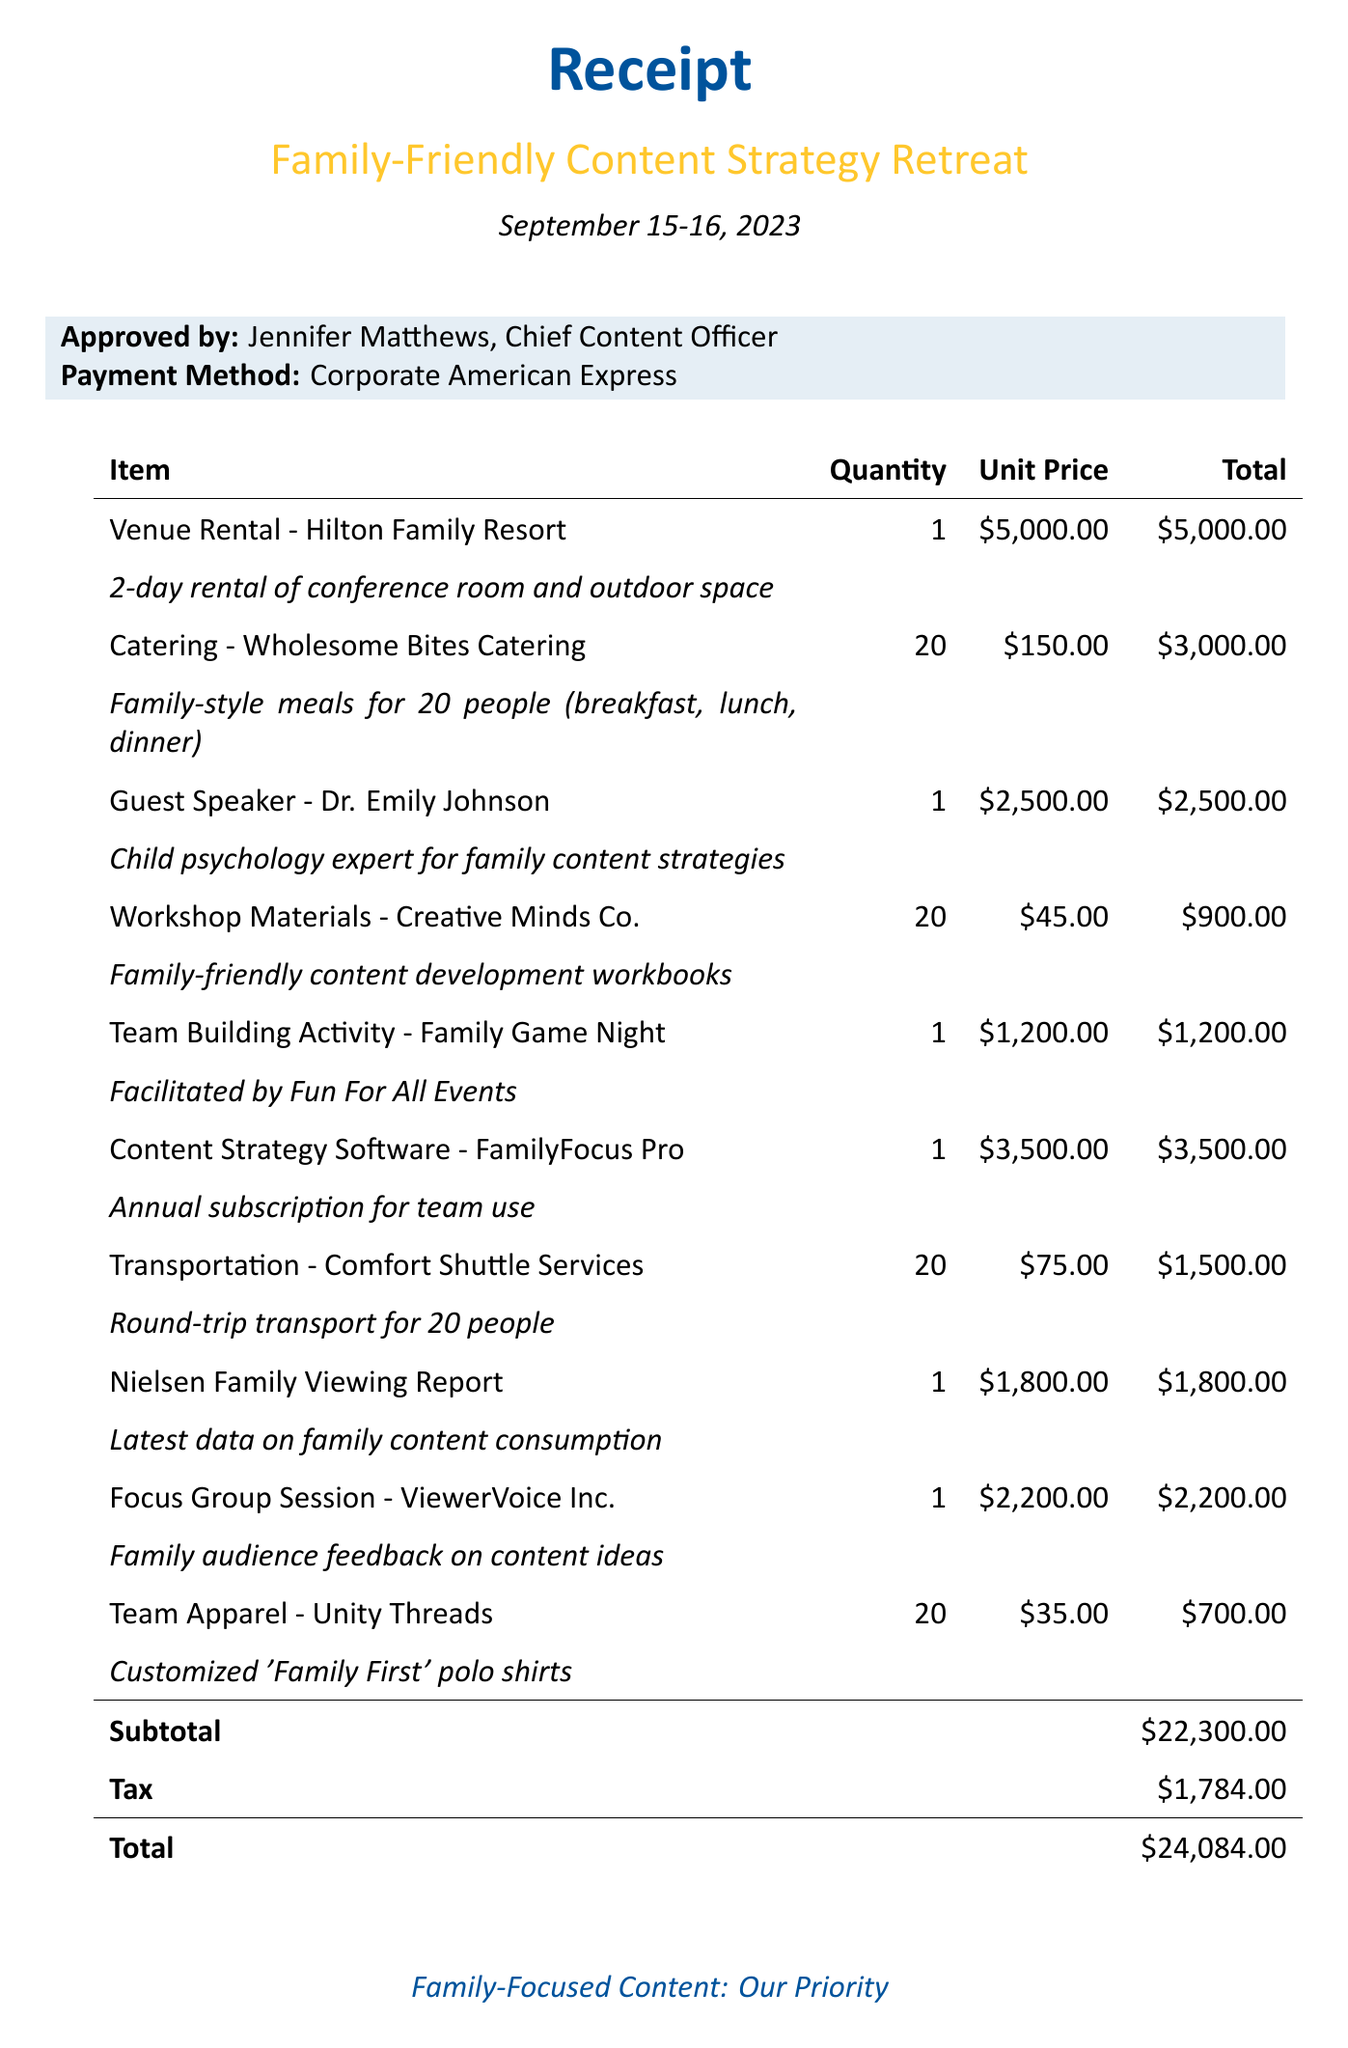What is the total amount of the receipt? The total amount is the final sum after tax, which is listed as $24084.00.
Answer: $24084.00 Who approved the receipt? The receipt is approved by Jennifer Matthews, who is the Chief Content Officer.
Answer: Jennifer Matthews What is the venue for the retreat? The venue listed for the retreat is Hilton Family Resort.
Answer: Hilton Family Resort How many people attended the retreat? The catering item specifies meals for 20 people, indicating the number of attendees.
Answer: 20 What is the total cost for the catering? The total cost for catering can be found by multiplying the unit price by the quantity, which is $150.00 x 20.
Answer: $3000.00 What is the date of the retreat? The document specifies that the retreat took place on September 15-16, 2023.
Answer: September 15-16, 2023 How much was spent on team apparel? The team apparel cost is listed as $700.00 in the document.
Answer: $700.00 What type of meals were provided during the retreat? The meals provided were family-style, as specified in the catering description.
Answer: Family-style What was the purpose of hiring the guest speaker? The guest speaker was hired as a child psychology expert for family content strategies.
Answer: Family content strategies 